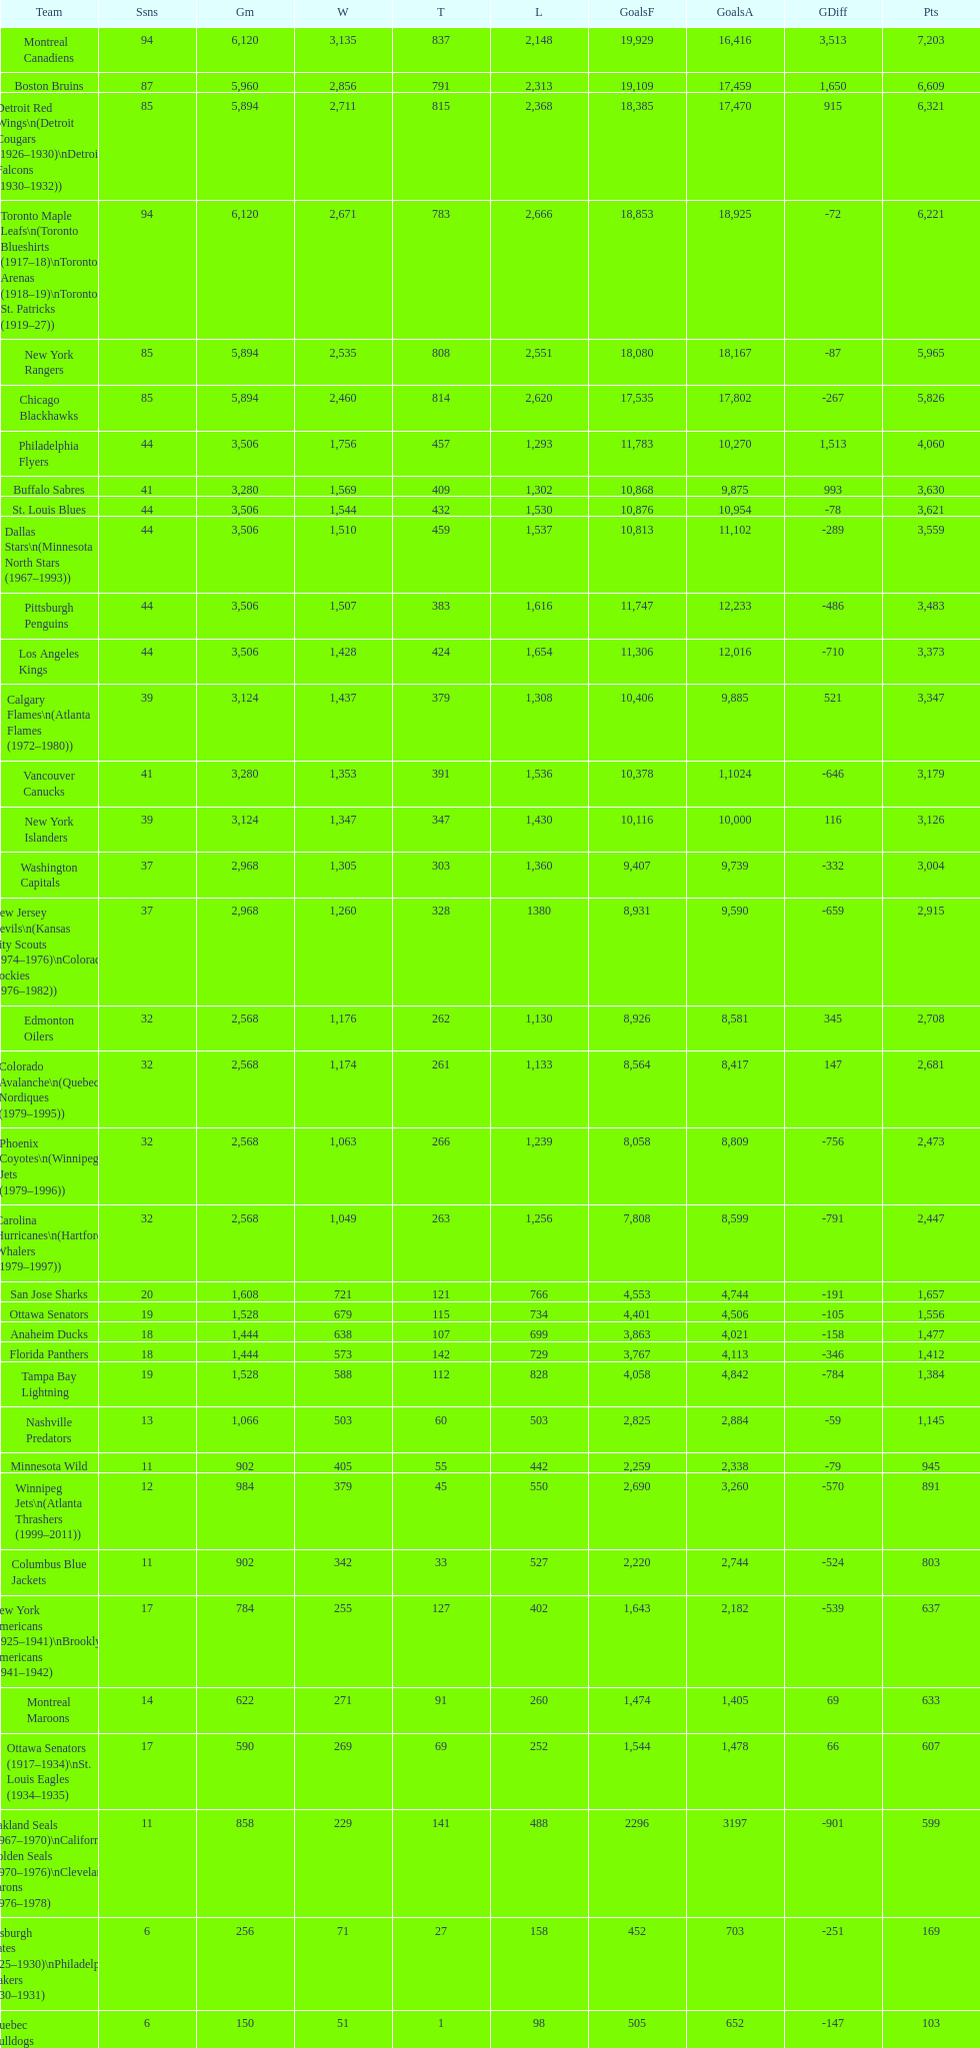What is the number of games that the vancouver canucks have won up to this point? 1,353. 